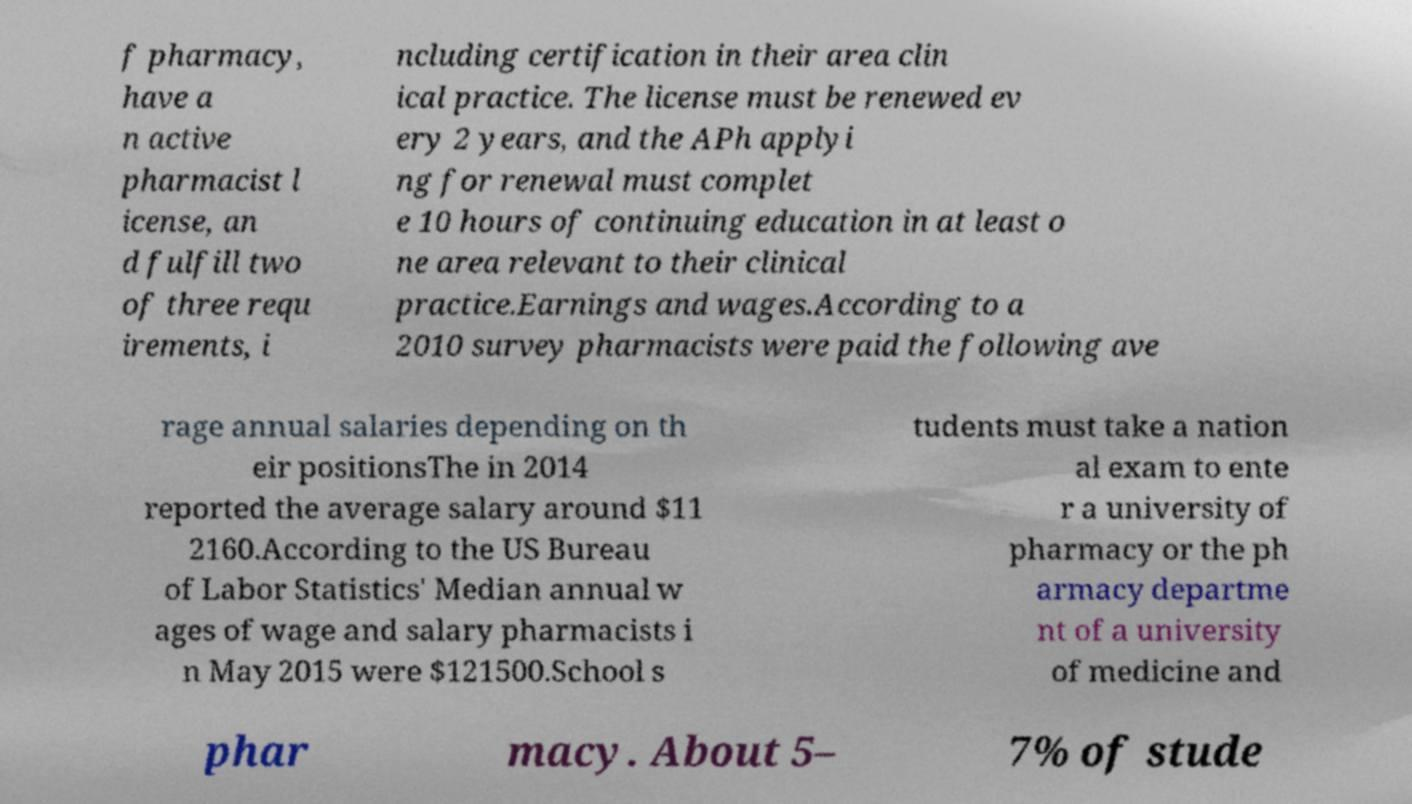Can you accurately transcribe the text from the provided image for me? f pharmacy, have a n active pharmacist l icense, an d fulfill two of three requ irements, i ncluding certification in their area clin ical practice. The license must be renewed ev ery 2 years, and the APh applyi ng for renewal must complet e 10 hours of continuing education in at least o ne area relevant to their clinical practice.Earnings and wages.According to a 2010 survey pharmacists were paid the following ave rage annual salaries depending on th eir positionsThe in 2014 reported the average salary around $11 2160.According to the US Bureau of Labor Statistics' Median annual w ages of wage and salary pharmacists i n May 2015 were $121500.School s tudents must take a nation al exam to ente r a university of pharmacy or the ph armacy departme nt of a university of medicine and phar macy. About 5– 7% of stude 